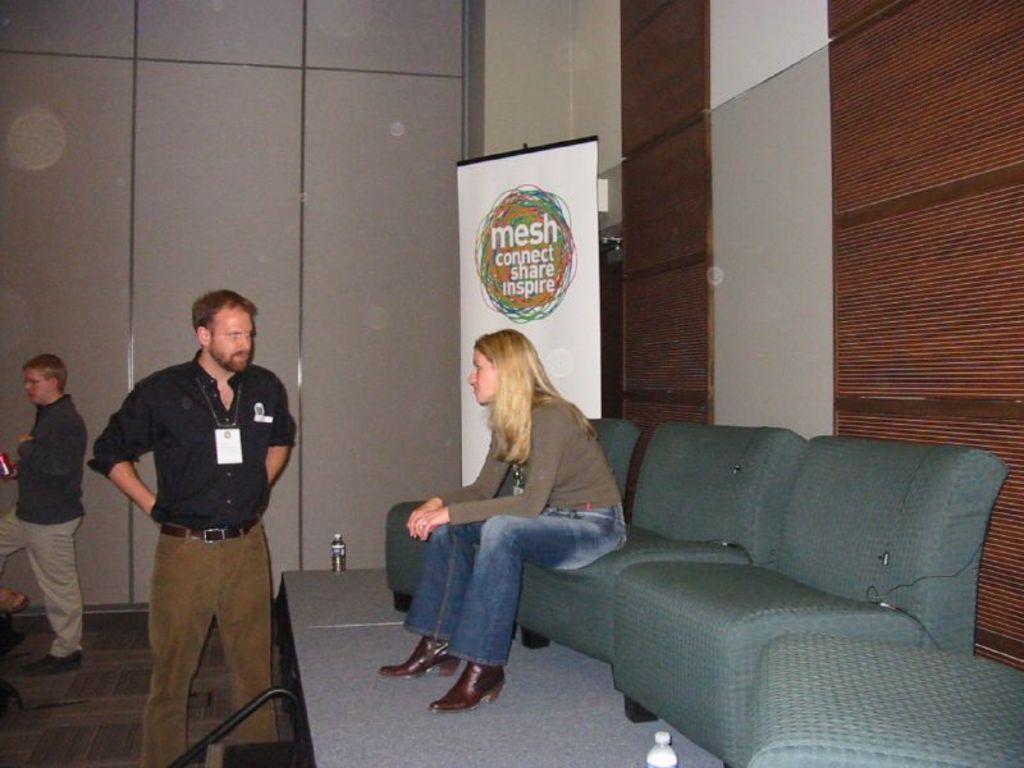Describe this image in one or two sentences. In this Image I see 2 men who are standing and I see a woman who is sitting on a chair, I can also there are 3 chairs over here and 2 bottles. In the background I see a banner and the wall. 